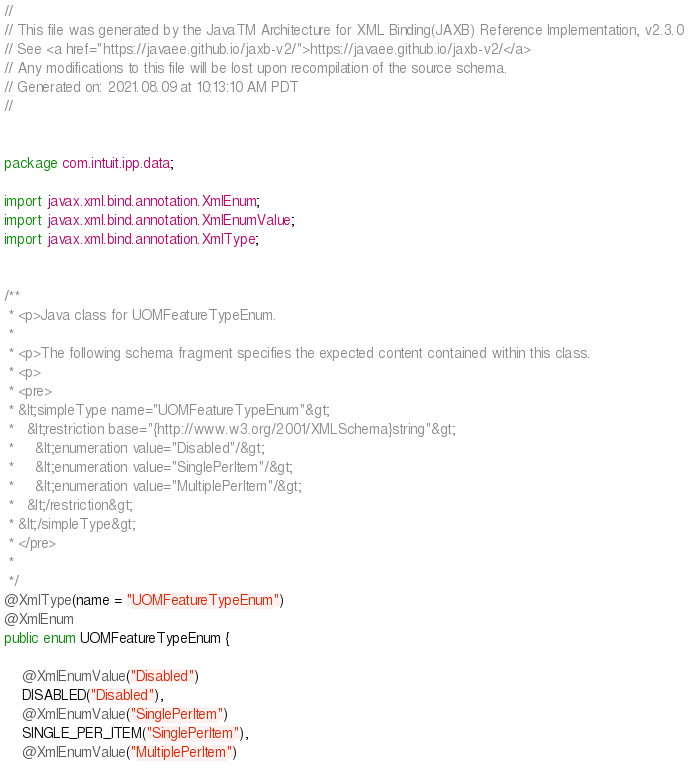<code> <loc_0><loc_0><loc_500><loc_500><_Java_>//
// This file was generated by the JavaTM Architecture for XML Binding(JAXB) Reference Implementation, v2.3.0 
// See <a href="https://javaee.github.io/jaxb-v2/">https://javaee.github.io/jaxb-v2/</a> 
// Any modifications to this file will be lost upon recompilation of the source schema. 
// Generated on: 2021.08.09 at 10:13:10 AM PDT 
//


package com.intuit.ipp.data;

import javax.xml.bind.annotation.XmlEnum;
import javax.xml.bind.annotation.XmlEnumValue;
import javax.xml.bind.annotation.XmlType;


/**
 * <p>Java class for UOMFeatureTypeEnum.
 * 
 * <p>The following schema fragment specifies the expected content contained within this class.
 * <p>
 * <pre>
 * &lt;simpleType name="UOMFeatureTypeEnum"&gt;
 *   &lt;restriction base="{http://www.w3.org/2001/XMLSchema}string"&gt;
 *     &lt;enumeration value="Disabled"/&gt;
 *     &lt;enumeration value="SinglePerItem"/&gt;
 *     &lt;enumeration value="MultiplePerItem"/&gt;
 *   &lt;/restriction&gt;
 * &lt;/simpleType&gt;
 * </pre>
 * 
 */
@XmlType(name = "UOMFeatureTypeEnum")
@XmlEnum
public enum UOMFeatureTypeEnum {

    @XmlEnumValue("Disabled")
    DISABLED("Disabled"),
    @XmlEnumValue("SinglePerItem")
    SINGLE_PER_ITEM("SinglePerItem"),
    @XmlEnumValue("MultiplePerItem")</code> 